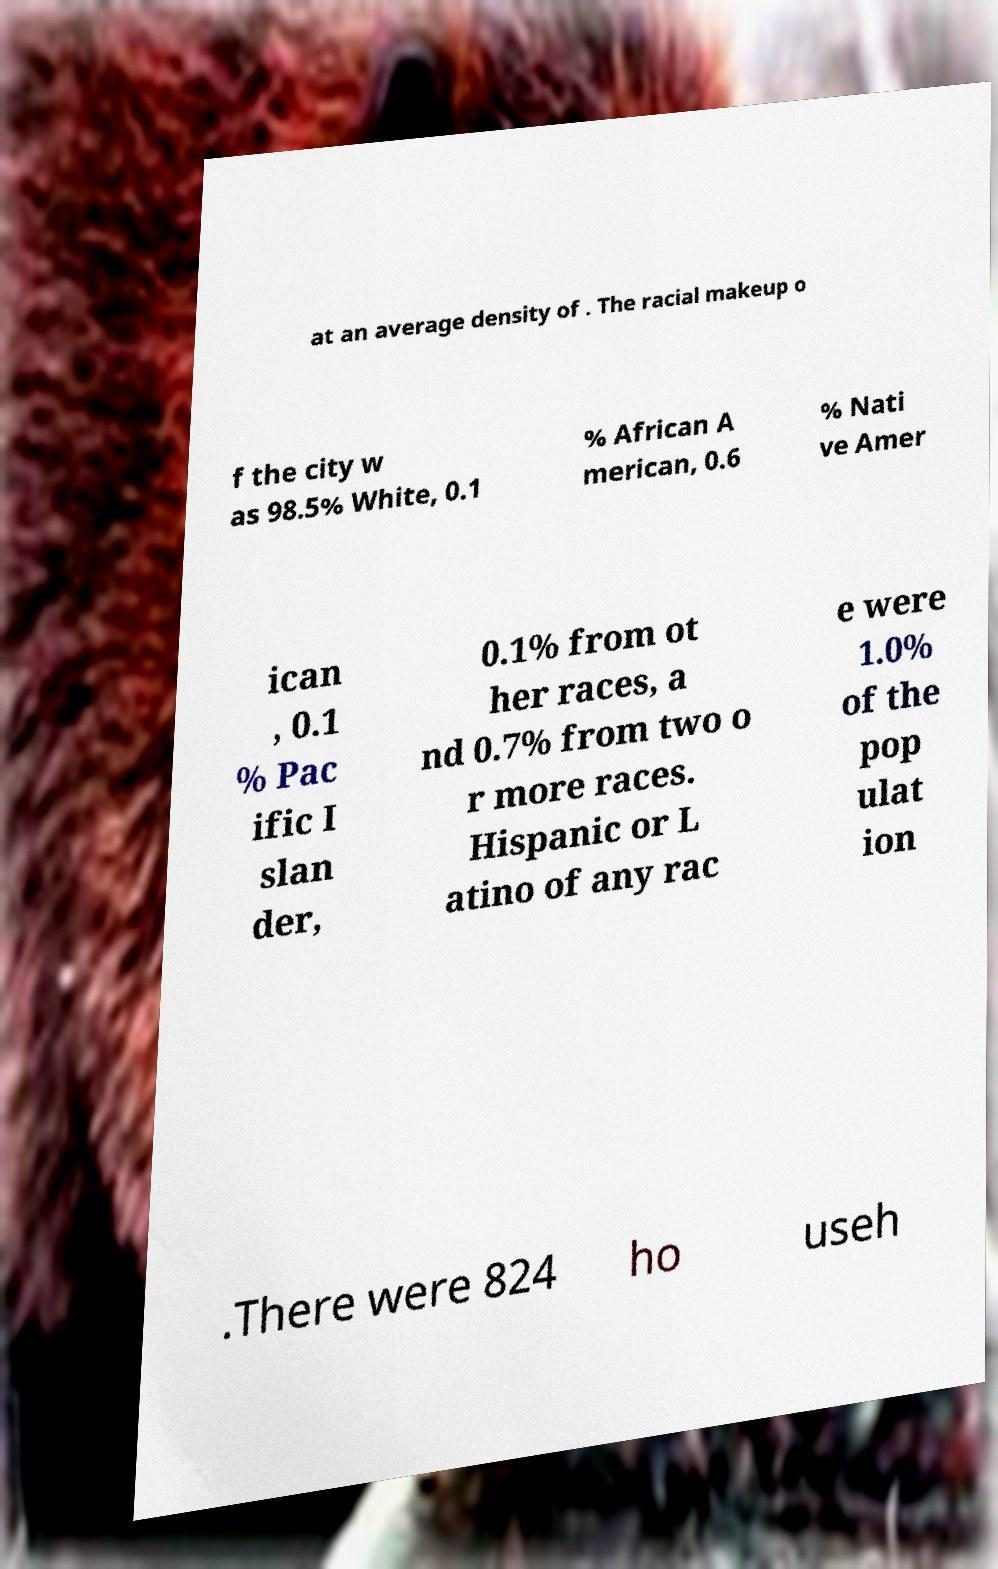There's text embedded in this image that I need extracted. Can you transcribe it verbatim? at an average density of . The racial makeup o f the city w as 98.5% White, 0.1 % African A merican, 0.6 % Nati ve Amer ican , 0.1 % Pac ific I slan der, 0.1% from ot her races, a nd 0.7% from two o r more races. Hispanic or L atino of any rac e were 1.0% of the pop ulat ion .There were 824 ho useh 